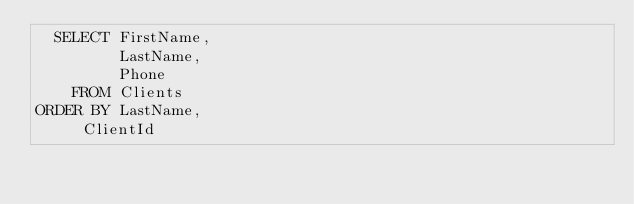Convert code to text. <code><loc_0><loc_0><loc_500><loc_500><_SQL_>  SELECT FirstName,
  	     LastName,
  	     Phone
    FROM Clients
ORDER BY LastName,
		 ClientId</code> 